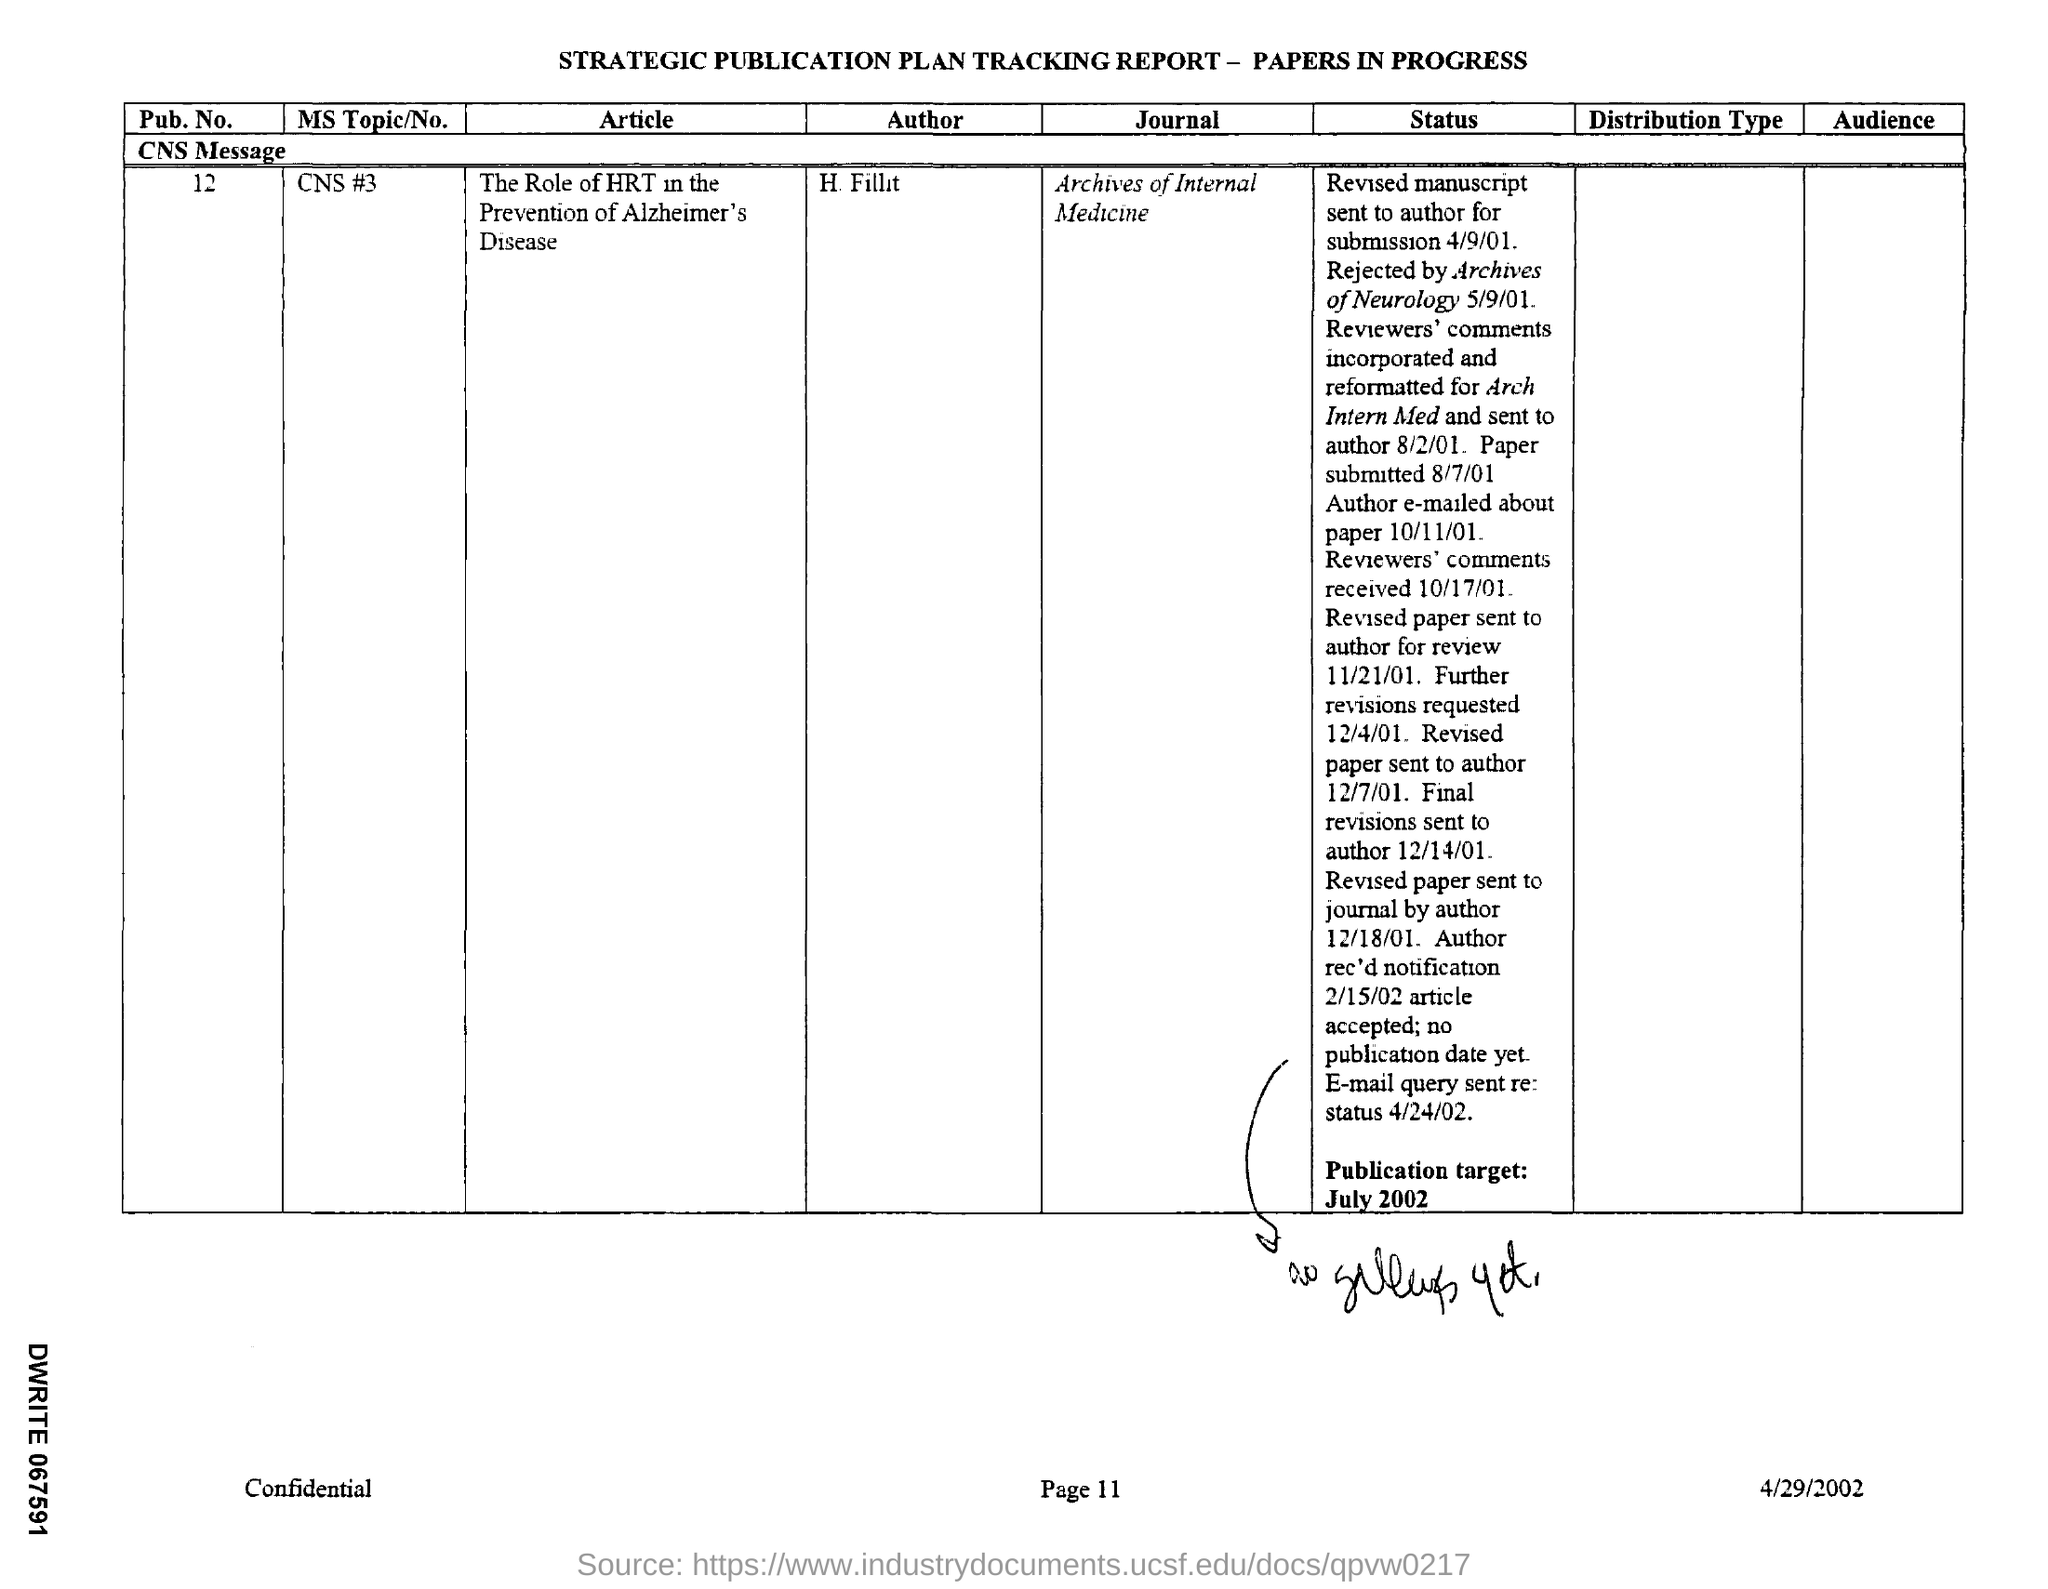Mention a couple of crucial points in this snapshot. The date on the document is April 29th, 2002. The journal is the Archives of Internal Medicine. 